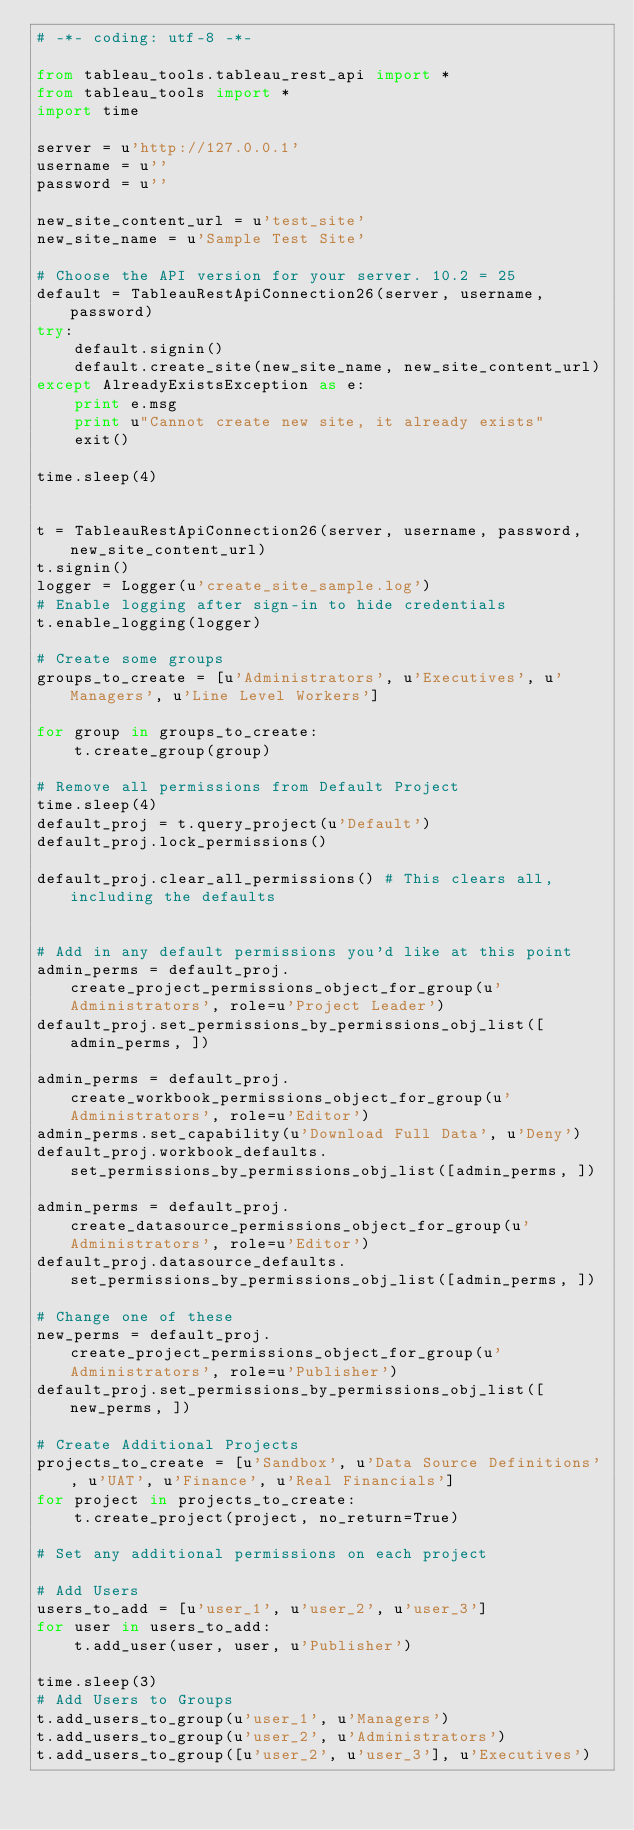Convert code to text. <code><loc_0><loc_0><loc_500><loc_500><_Python_># -*- coding: utf-8 -*-

from tableau_tools.tableau_rest_api import *
from tableau_tools import *
import time

server = u'http://127.0.0.1'
username = u''
password = u''

new_site_content_url = u'test_site'
new_site_name = u'Sample Test Site'

# Choose the API version for your server. 10.2 = 25
default = TableauRestApiConnection26(server, username, password)
try:
    default.signin()
    default.create_site(new_site_name, new_site_content_url)
except AlreadyExistsException as e:
    print e.msg
    print u"Cannot create new site, it already exists"
    exit()

time.sleep(4)


t = TableauRestApiConnection26(server, username, password, new_site_content_url)
t.signin()
logger = Logger(u'create_site_sample.log')
# Enable logging after sign-in to hide credentials
t.enable_logging(logger)

# Create some groups
groups_to_create = [u'Administrators', u'Executives', u'Managers', u'Line Level Workers']

for group in groups_to_create:
    t.create_group(group)

# Remove all permissions from Default Project
time.sleep(4)
default_proj = t.query_project(u'Default')
default_proj.lock_permissions()

default_proj.clear_all_permissions() # This clears all, including the defaults


# Add in any default permissions you'd like at this point
admin_perms = default_proj.create_project_permissions_object_for_group(u'Administrators', role=u'Project Leader')
default_proj.set_permissions_by_permissions_obj_list([admin_perms, ])

admin_perms = default_proj.create_workbook_permissions_object_for_group(u'Administrators', role=u'Editor')
admin_perms.set_capability(u'Download Full Data', u'Deny')
default_proj.workbook_defaults.set_permissions_by_permissions_obj_list([admin_perms, ])

admin_perms = default_proj.create_datasource_permissions_object_for_group(u'Administrators', role=u'Editor')
default_proj.datasource_defaults.set_permissions_by_permissions_obj_list([admin_perms, ])

# Change one of these
new_perms = default_proj.create_project_permissions_object_for_group(u'Administrators', role=u'Publisher')
default_proj.set_permissions_by_permissions_obj_list([new_perms, ])

# Create Additional Projects
projects_to_create = [u'Sandbox', u'Data Source Definitions', u'UAT', u'Finance', u'Real Financials']
for project in projects_to_create:
    t.create_project(project, no_return=True)

# Set any additional permissions on each project

# Add Users
users_to_add = [u'user_1', u'user_2', u'user_3']
for user in users_to_add:
    t.add_user(user, user, u'Publisher')

time.sleep(3)
# Add Users to Groups
t.add_users_to_group(u'user_1', u'Managers')
t.add_users_to_group(u'user_2', u'Administrators')
t.add_users_to_group([u'user_2', u'user_3'], u'Executives')
</code> 